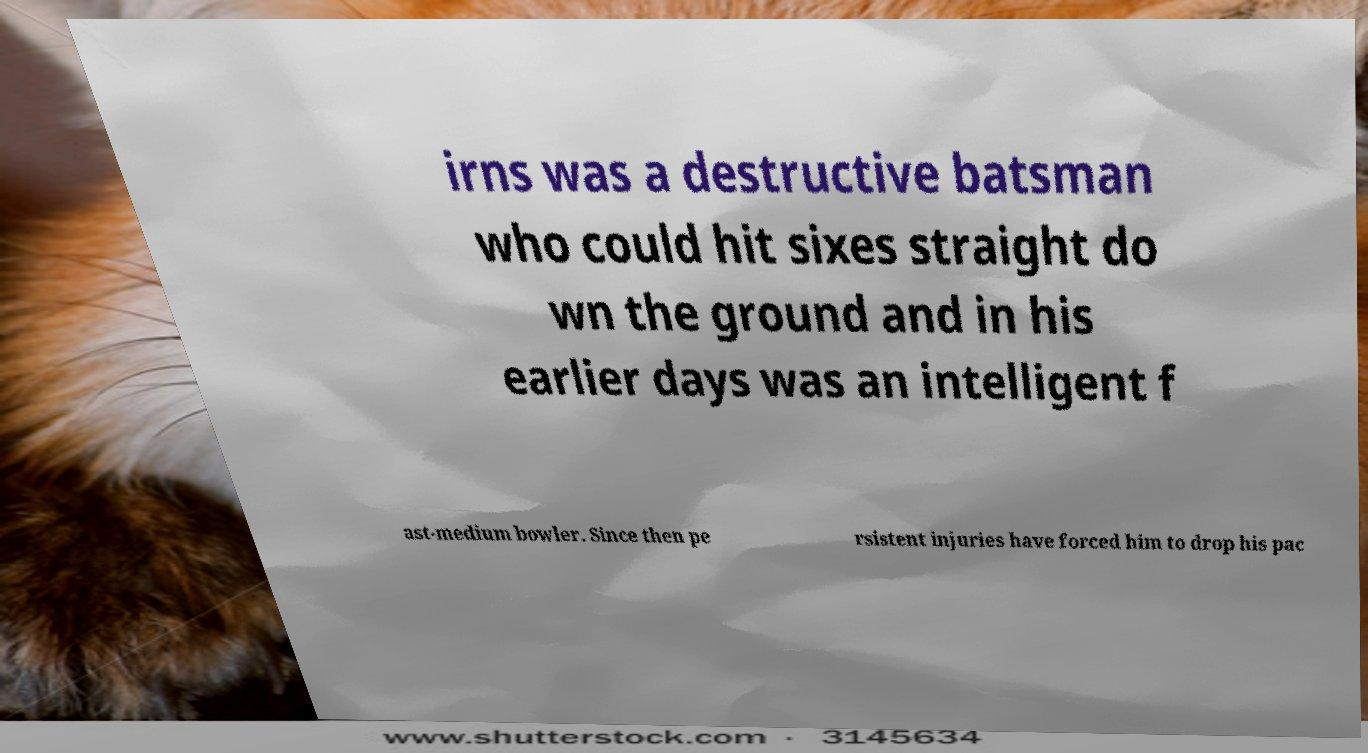There's text embedded in this image that I need extracted. Can you transcribe it verbatim? irns was a destructive batsman who could hit sixes straight do wn the ground and in his earlier days was an intelligent f ast-medium bowler. Since then pe rsistent injuries have forced him to drop his pac 